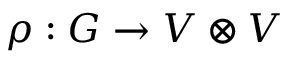Convert formula to latex. <formula><loc_0><loc_0><loc_500><loc_500>\rho \colon G \to V \otimes V</formula> 